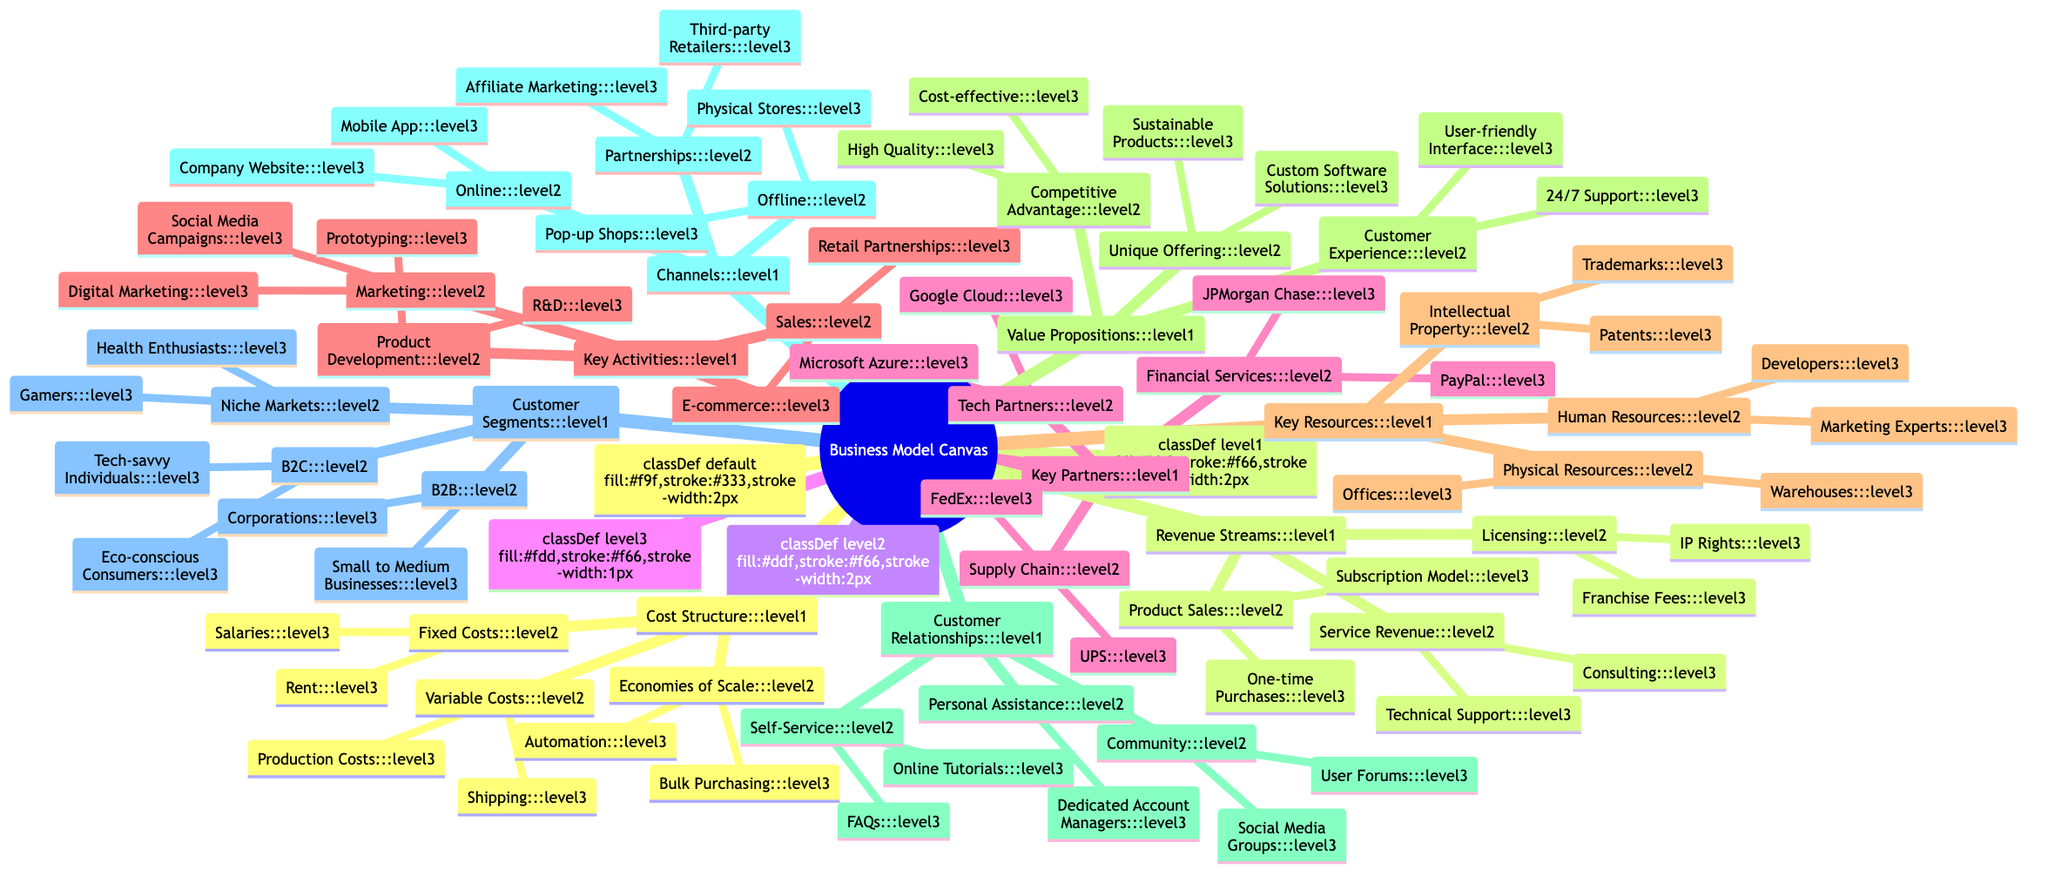What are the two tech partners listed? The diagram lists under "Key Partners" the tech partners as "Google Cloud" and "Microsoft Azure".
Answer: Google Cloud, Microsoft Azure How many channels are mentioned in the diagram? The diagram lists three main types of channels: "Online", "Offline", and "Partnerships", which can be identified as the main branches under "Channels".
Answer: 3 What are the unique offerings of the value propositions? The unique offerings under "Value Propositions" are "Custom Software Solutions" and "Sustainable Products".
Answer: Custom Software Solutions, Sustainable Products Which customer segment is described as "Eco-conscious Consumers"? In the "Customer Segments", the group "Eco-conscious Consumers" is categorized under "B2C", which targets tech-savvy individuals and others who have an interest in sustainability.
Answer: B2C What do the fixed costs include? The "Cost Structure" specifies "Rent" and "Salaries" as the elements included in fixed costs, making it easy to identify the types of expenses represented.
Answer: Rent, Salaries What activities fall under product development? The "Key Activities" section outlines "R&D" and "Prototyping" as activities within the product development category, identifying specific efforts in this area.
Answer: R&D, Prototyping Which relationships are characterized by “Dedicated Account Managers”? Under "Customer Relationships", "Personal Assistance" includes "Dedicated Account Managers", indicating a personalized service level offered to customers.
Answer: Personal Assistance What type of revenue stream includes "Franchise Fees"? The "Revenue Streams" section defines "Licensing" as the category that includes "IP Rights" and "Franchise Fees", showing the nature of revenue-generating practices.
Answer: Licensing 